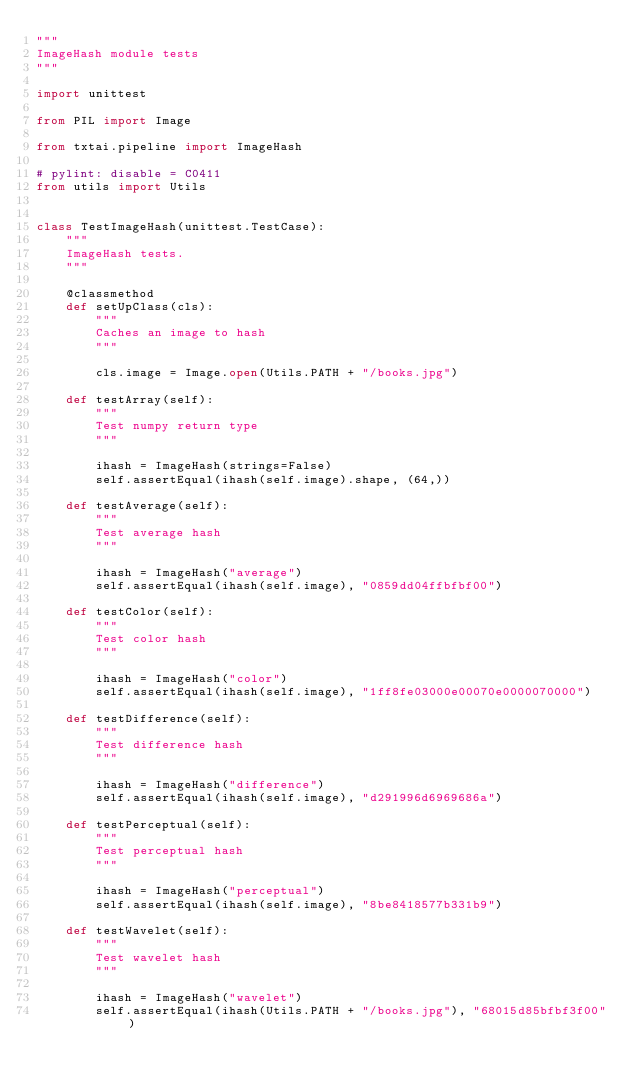Convert code to text. <code><loc_0><loc_0><loc_500><loc_500><_Python_>"""
ImageHash module tests
"""

import unittest

from PIL import Image

from txtai.pipeline import ImageHash

# pylint: disable = C0411
from utils import Utils


class TestImageHash(unittest.TestCase):
    """
    ImageHash tests.
    """

    @classmethod
    def setUpClass(cls):
        """
        Caches an image to hash
        """

        cls.image = Image.open(Utils.PATH + "/books.jpg")

    def testArray(self):
        """
        Test numpy return type
        """

        ihash = ImageHash(strings=False)
        self.assertEqual(ihash(self.image).shape, (64,))

    def testAverage(self):
        """
        Test average hash
        """

        ihash = ImageHash("average")
        self.assertEqual(ihash(self.image), "0859dd04ffbfbf00")

    def testColor(self):
        """
        Test color hash
        """

        ihash = ImageHash("color")
        self.assertEqual(ihash(self.image), "1ff8fe03000e00070e0000070000")

    def testDifference(self):
        """
        Test difference hash
        """

        ihash = ImageHash("difference")
        self.assertEqual(ihash(self.image), "d291996d6969686a")

    def testPerceptual(self):
        """
        Test perceptual hash
        """

        ihash = ImageHash("perceptual")
        self.assertEqual(ihash(self.image), "8be8418577b331b9")

    def testWavelet(self):
        """
        Test wavelet hash
        """

        ihash = ImageHash("wavelet")
        self.assertEqual(ihash(Utils.PATH + "/books.jpg"), "68015d85bfbf3f00")
</code> 